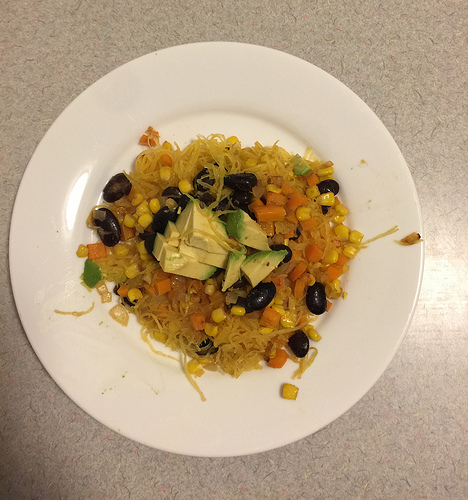<image>
Is there a plate under the snacks? Yes. The plate is positioned underneath the snacks, with the snacks above it in the vertical space. 